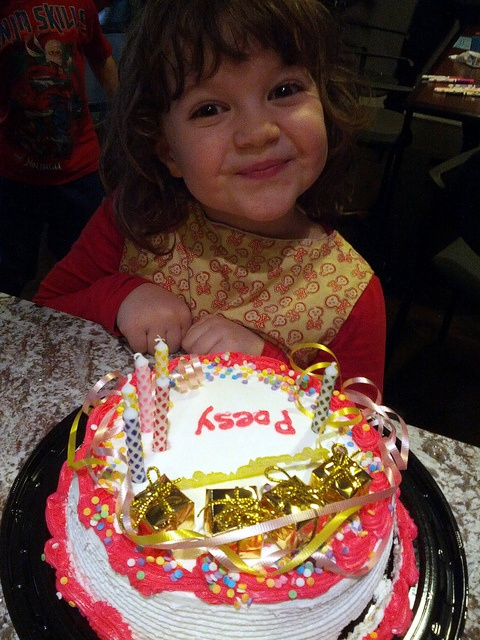Describe the objects in this image and their specific colors. I can see people in black, maroon, and brown tones, cake in black, lightgray, brown, darkgray, and salmon tones, and people in black, maroon, and brown tones in this image. 